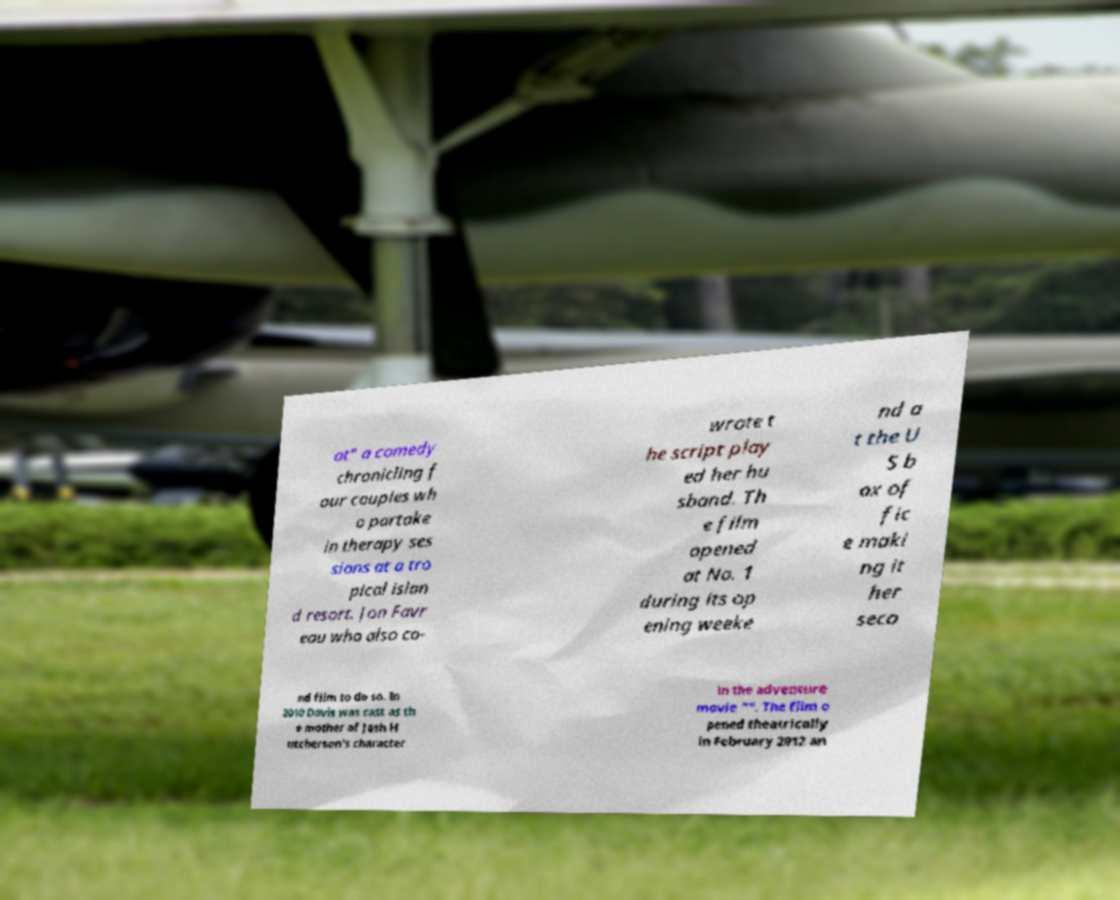Could you extract and type out the text from this image? at" a comedy chronicling f our couples wh o partake in therapy ses sions at a tro pical islan d resort. Jon Favr eau who also co- wrote t he script play ed her hu sband. Th e film opened at No. 1 during its op ening weeke nd a t the U S b ox of fic e maki ng it her seco nd film to do so. In 2010 Davis was cast as th e mother of Josh H utcherson's character in the adventure movie "". The film o pened theatrically in February 2012 an 